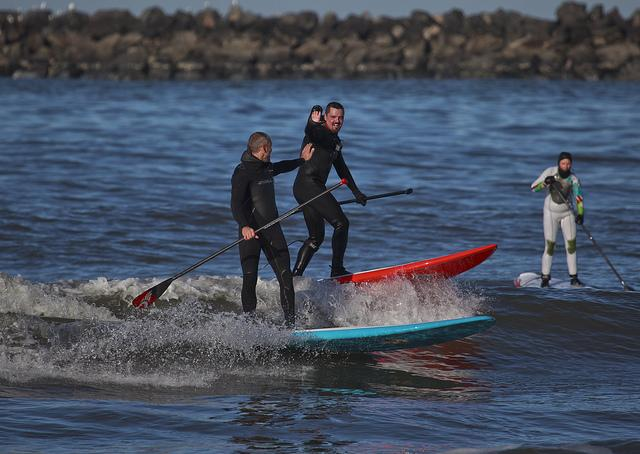Which artist depicted Polynesians practicing this sport on the Sandwich Islands? john webber 